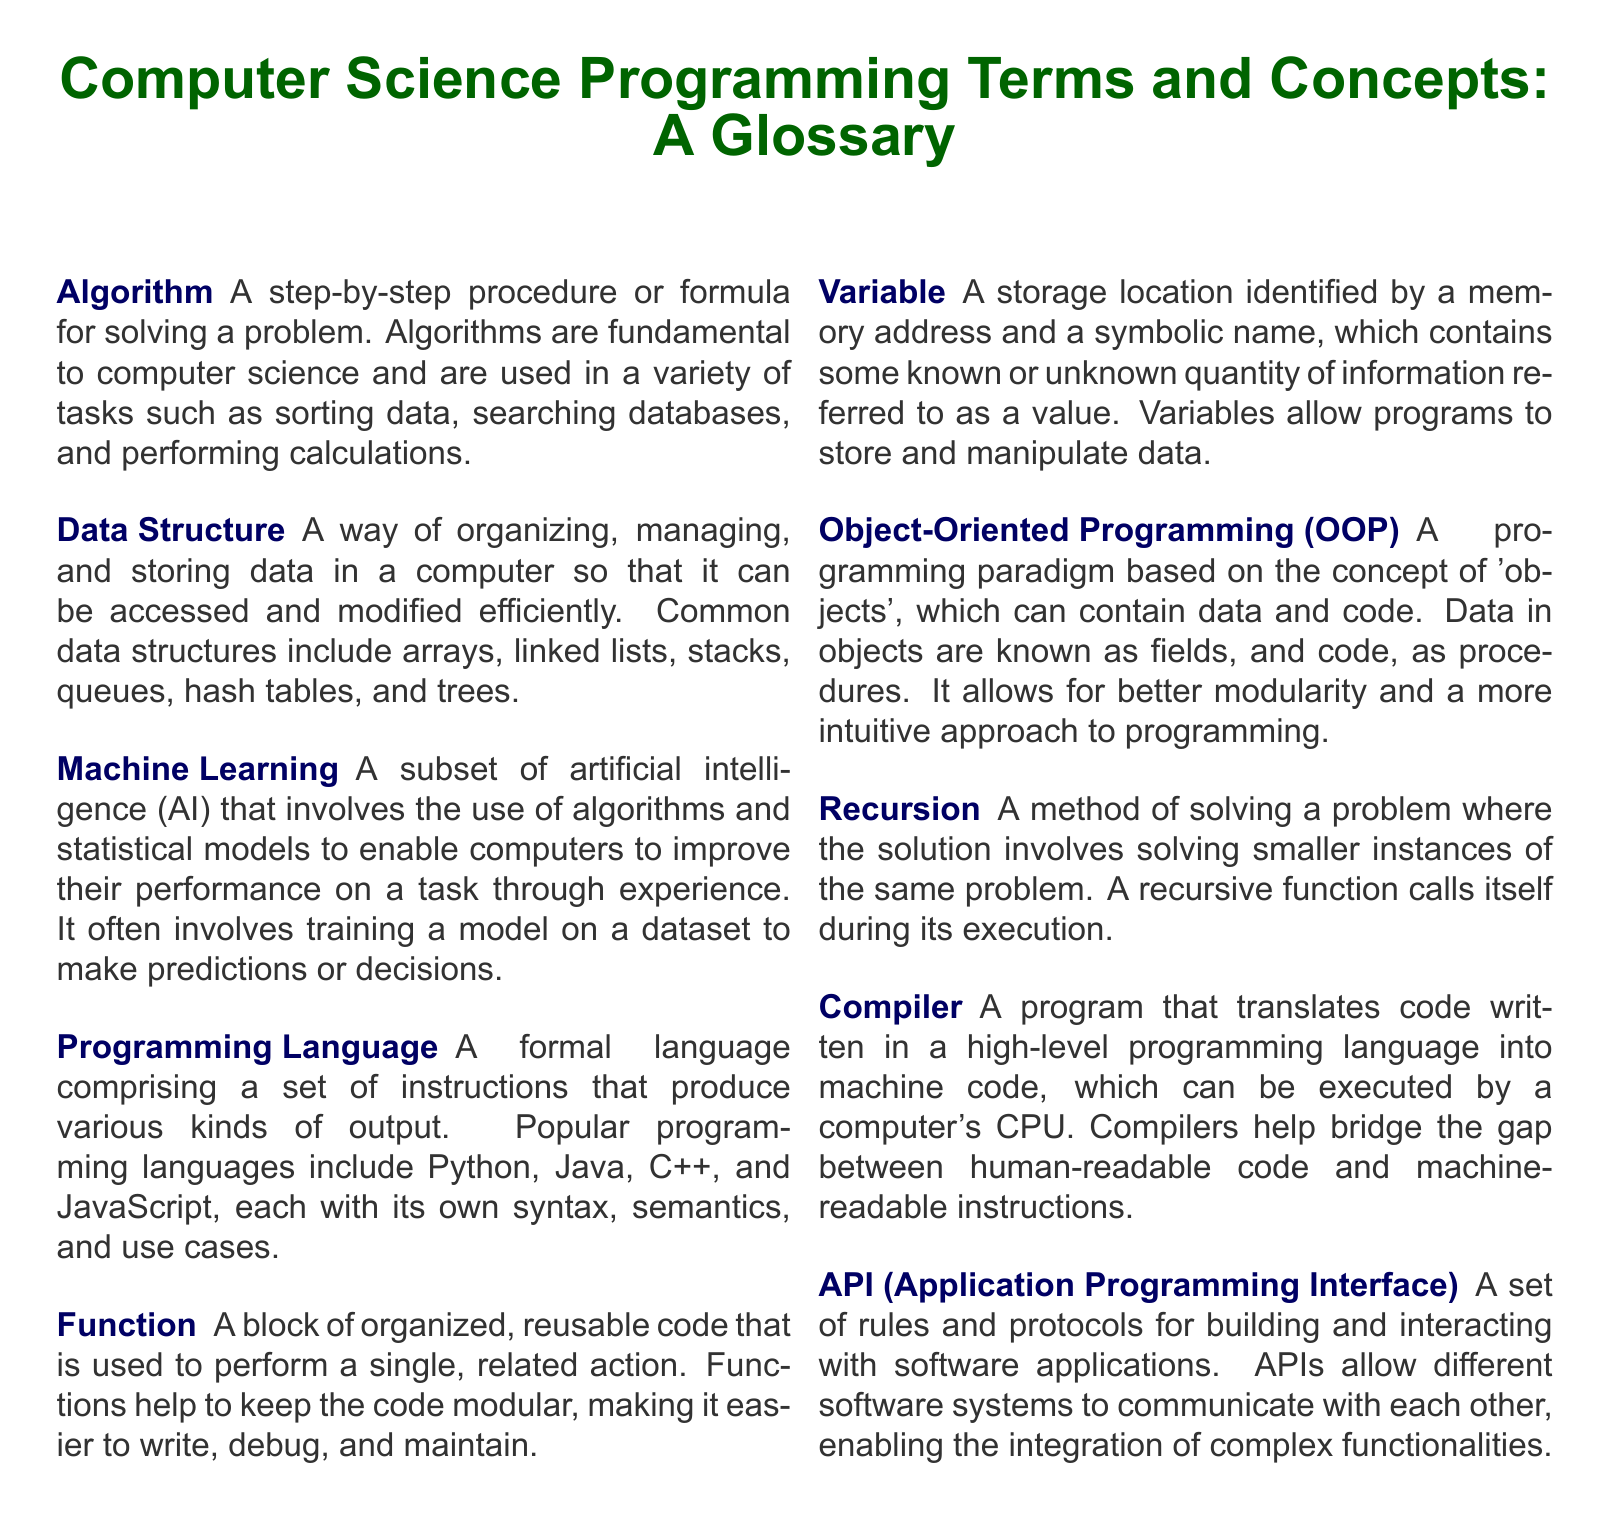What is the term for a step-by-step procedure for solving a problem? The document defines "Algorithm" as a step-by-step procedure or formula for solving a problem.
Answer: Algorithm What are the two popular programming languages mentioned? The document gives examples of popular programming languages, including Python and Java.
Answer: Python, Java What does OOP stand for? The glossary acronym "OOP" refers to Object-Oriented Programming.
Answer: Object-Oriented Programming What is the primary focus of Machine Learning? The document describes Machine Learning as a subset of artificial intelligence focusing on improving performance through experience.
Answer: Improving performance through experience What is a recursive method? The document explains recursion as a method of solving a problem by solving smaller instances of the same problem.
Answer: Solving smaller instances What is the purpose of a Compiler? According to the document, a Compiler translates high-level programming language code into machine code.
Answer: Translates code into machine code What does API stand for? The term "API" in the document is defined as Application Programming Interface.
Answer: Application Programming Interface How many data structures are commonly listed? The document mentions several common data structures, which include at least six types.
Answer: Six types What is a variable? The document defines a variable as a storage location identified by a memory address containing information known as a value.
Answer: Storage location containing information 